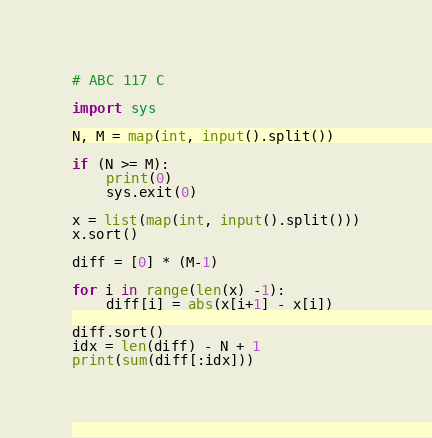<code> <loc_0><loc_0><loc_500><loc_500><_Python_># ABC 117 C

import sys

N, M = map(int, input().split())

if (N >= M):
    print(0)
    sys.exit(0)

x = list(map(int, input().split()))
x.sort()

diff = [0] * (M-1)

for i in range(len(x) -1):
    diff[i] = abs(x[i+1] - x[i])

diff.sort()
idx = len(diff) - N + 1
print(sum(diff[:idx]))
</code> 